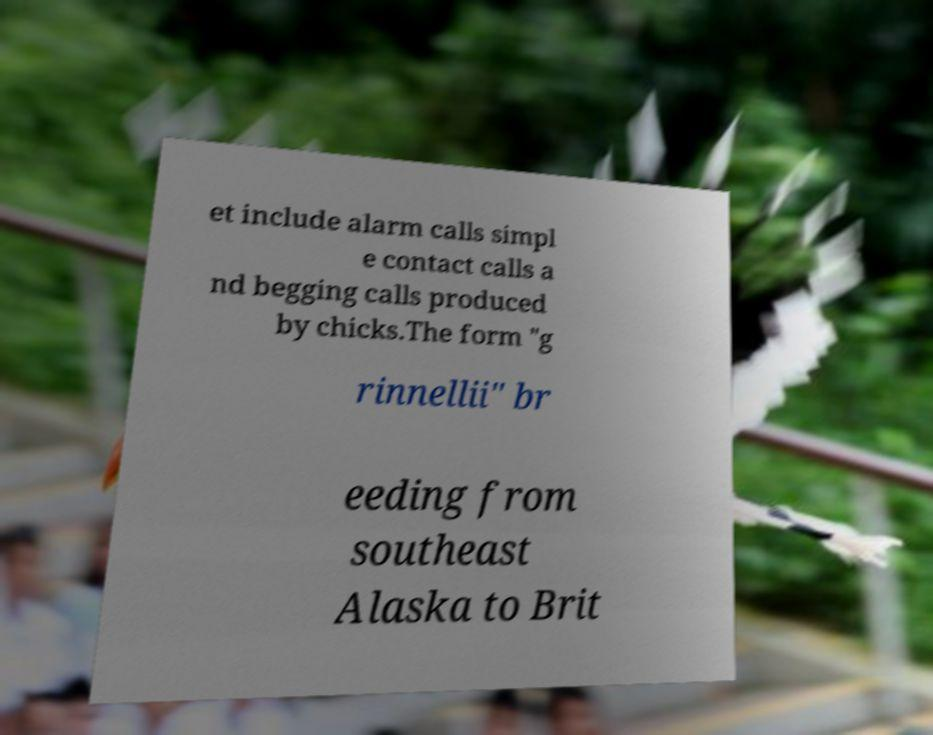Could you assist in decoding the text presented in this image and type it out clearly? et include alarm calls simpl e contact calls a nd begging calls produced by chicks.The form "g rinnellii" br eeding from southeast Alaska to Brit 